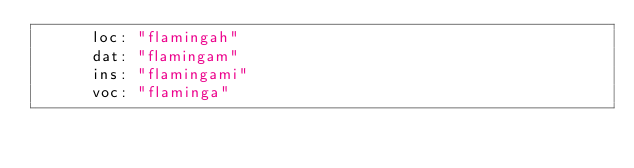<code> <loc_0><loc_0><loc_500><loc_500><_YAML_>      loc: "flamingah"
      dat: "flamingam"
      ins: "flamingami"
      voc: "flaminga"
</code> 